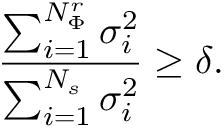Convert formula to latex. <formula><loc_0><loc_0><loc_500><loc_500>\frac { \sum _ { i = 1 } ^ { N _ { \Phi } ^ { r } } \sigma _ { i } ^ { 2 } } { \sum _ { i = 1 } ^ { N _ { s } } \sigma _ { i } ^ { 2 } } \geq \delta .</formula> 